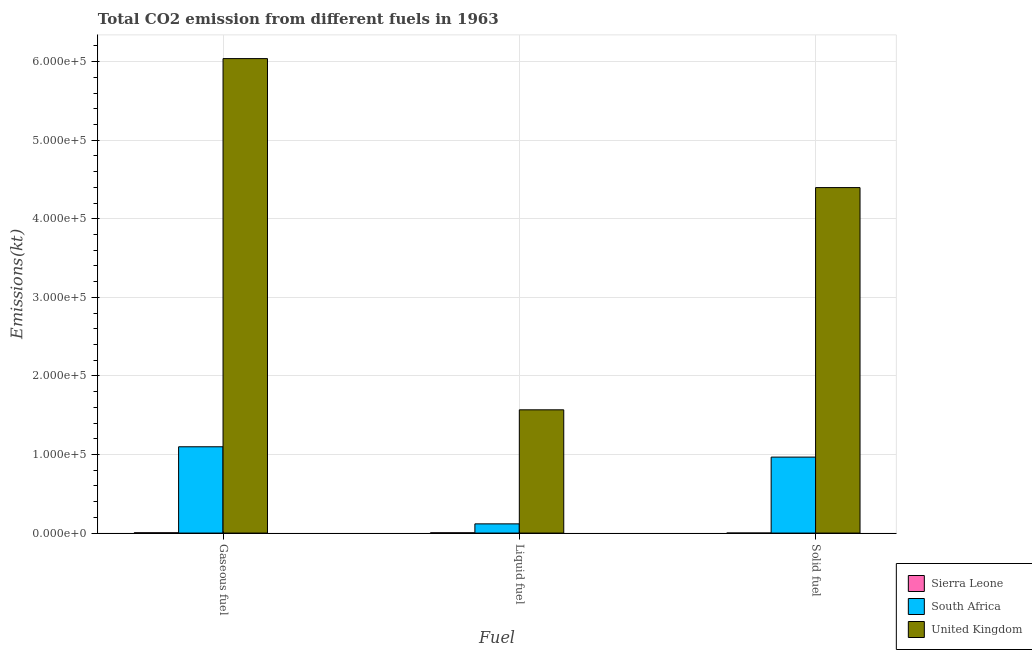How many groups of bars are there?
Provide a succinct answer. 3. Are the number of bars per tick equal to the number of legend labels?
Ensure brevity in your answer.  Yes. How many bars are there on the 2nd tick from the right?
Make the answer very short. 3. What is the label of the 3rd group of bars from the left?
Give a very brief answer. Solid fuel. What is the amount of co2 emissions from gaseous fuel in South Africa?
Make the answer very short. 1.10e+05. Across all countries, what is the maximum amount of co2 emissions from gaseous fuel?
Offer a very short reply. 6.04e+05. Across all countries, what is the minimum amount of co2 emissions from liquid fuel?
Your answer should be very brief. 355.7. In which country was the amount of co2 emissions from gaseous fuel maximum?
Offer a terse response. United Kingdom. In which country was the amount of co2 emissions from liquid fuel minimum?
Offer a very short reply. Sierra Leone. What is the total amount of co2 emissions from liquid fuel in the graph?
Give a very brief answer. 1.69e+05. What is the difference between the amount of co2 emissions from gaseous fuel in South Africa and that in Sierra Leone?
Offer a very short reply. 1.09e+05. What is the difference between the amount of co2 emissions from solid fuel in Sierra Leone and the amount of co2 emissions from gaseous fuel in United Kingdom?
Keep it short and to the point. -6.04e+05. What is the average amount of co2 emissions from solid fuel per country?
Make the answer very short. 1.79e+05. What is the difference between the amount of co2 emissions from solid fuel and amount of co2 emissions from gaseous fuel in South Africa?
Offer a very short reply. -1.31e+04. In how many countries, is the amount of co2 emissions from solid fuel greater than 160000 kt?
Provide a short and direct response. 1. What is the ratio of the amount of co2 emissions from solid fuel in South Africa to that in United Kingdom?
Offer a terse response. 0.22. Is the amount of co2 emissions from gaseous fuel in United Kingdom less than that in South Africa?
Offer a terse response. No. Is the difference between the amount of co2 emissions from gaseous fuel in South Africa and Sierra Leone greater than the difference between the amount of co2 emissions from solid fuel in South Africa and Sierra Leone?
Provide a short and direct response. Yes. What is the difference between the highest and the second highest amount of co2 emissions from liquid fuel?
Keep it short and to the point. 1.45e+05. What is the difference between the highest and the lowest amount of co2 emissions from liquid fuel?
Offer a terse response. 1.57e+05. Is the sum of the amount of co2 emissions from solid fuel in United Kingdom and Sierra Leone greater than the maximum amount of co2 emissions from gaseous fuel across all countries?
Make the answer very short. No. What does the 2nd bar from the left in Solid fuel represents?
Your answer should be compact. South Africa. What does the 2nd bar from the right in Gaseous fuel represents?
Your answer should be very brief. South Africa. How many bars are there?
Keep it short and to the point. 9. Are all the bars in the graph horizontal?
Keep it short and to the point. No. What is the difference between two consecutive major ticks on the Y-axis?
Offer a very short reply. 1.00e+05. Where does the legend appear in the graph?
Make the answer very short. Bottom right. How many legend labels are there?
Ensure brevity in your answer.  3. How are the legend labels stacked?
Offer a terse response. Vertical. What is the title of the graph?
Offer a very short reply. Total CO2 emission from different fuels in 1963. What is the label or title of the X-axis?
Your response must be concise. Fuel. What is the label or title of the Y-axis?
Provide a short and direct response. Emissions(kt). What is the Emissions(kt) of Sierra Leone in Gaseous fuel?
Ensure brevity in your answer.  370.37. What is the Emissions(kt) of South Africa in Gaseous fuel?
Provide a short and direct response. 1.10e+05. What is the Emissions(kt) of United Kingdom in Gaseous fuel?
Make the answer very short. 6.04e+05. What is the Emissions(kt) of Sierra Leone in Liquid fuel?
Offer a very short reply. 355.7. What is the Emissions(kt) of South Africa in Liquid fuel?
Ensure brevity in your answer.  1.17e+04. What is the Emissions(kt) of United Kingdom in Liquid fuel?
Give a very brief answer. 1.57e+05. What is the Emissions(kt) of Sierra Leone in Solid fuel?
Provide a short and direct response. 14.67. What is the Emissions(kt) of South Africa in Solid fuel?
Make the answer very short. 9.67e+04. What is the Emissions(kt) in United Kingdom in Solid fuel?
Provide a short and direct response. 4.40e+05. Across all Fuel, what is the maximum Emissions(kt) of Sierra Leone?
Give a very brief answer. 370.37. Across all Fuel, what is the maximum Emissions(kt) of South Africa?
Ensure brevity in your answer.  1.10e+05. Across all Fuel, what is the maximum Emissions(kt) of United Kingdom?
Ensure brevity in your answer.  6.04e+05. Across all Fuel, what is the minimum Emissions(kt) in Sierra Leone?
Your answer should be compact. 14.67. Across all Fuel, what is the minimum Emissions(kt) of South Africa?
Provide a succinct answer. 1.17e+04. Across all Fuel, what is the minimum Emissions(kt) in United Kingdom?
Offer a very short reply. 1.57e+05. What is the total Emissions(kt) in Sierra Leone in the graph?
Make the answer very short. 740.73. What is the total Emissions(kt) of South Africa in the graph?
Offer a very short reply. 2.18e+05. What is the total Emissions(kt) of United Kingdom in the graph?
Your answer should be compact. 1.20e+06. What is the difference between the Emissions(kt) of Sierra Leone in Gaseous fuel and that in Liquid fuel?
Provide a short and direct response. 14.67. What is the difference between the Emissions(kt) of South Africa in Gaseous fuel and that in Liquid fuel?
Your answer should be compact. 9.81e+04. What is the difference between the Emissions(kt) of United Kingdom in Gaseous fuel and that in Liquid fuel?
Offer a very short reply. 4.47e+05. What is the difference between the Emissions(kt) of Sierra Leone in Gaseous fuel and that in Solid fuel?
Offer a very short reply. 355.7. What is the difference between the Emissions(kt) of South Africa in Gaseous fuel and that in Solid fuel?
Offer a very short reply. 1.31e+04. What is the difference between the Emissions(kt) of United Kingdom in Gaseous fuel and that in Solid fuel?
Keep it short and to the point. 1.64e+05. What is the difference between the Emissions(kt) of Sierra Leone in Liquid fuel and that in Solid fuel?
Offer a terse response. 341.03. What is the difference between the Emissions(kt) of South Africa in Liquid fuel and that in Solid fuel?
Your response must be concise. -8.50e+04. What is the difference between the Emissions(kt) in United Kingdom in Liquid fuel and that in Solid fuel?
Offer a terse response. -2.83e+05. What is the difference between the Emissions(kt) of Sierra Leone in Gaseous fuel and the Emissions(kt) of South Africa in Liquid fuel?
Your answer should be compact. -1.13e+04. What is the difference between the Emissions(kt) of Sierra Leone in Gaseous fuel and the Emissions(kt) of United Kingdom in Liquid fuel?
Offer a very short reply. -1.56e+05. What is the difference between the Emissions(kt) of South Africa in Gaseous fuel and the Emissions(kt) of United Kingdom in Liquid fuel?
Keep it short and to the point. -4.70e+04. What is the difference between the Emissions(kt) of Sierra Leone in Gaseous fuel and the Emissions(kt) of South Africa in Solid fuel?
Offer a terse response. -9.63e+04. What is the difference between the Emissions(kt) of Sierra Leone in Gaseous fuel and the Emissions(kt) of United Kingdom in Solid fuel?
Keep it short and to the point. -4.39e+05. What is the difference between the Emissions(kt) of South Africa in Gaseous fuel and the Emissions(kt) of United Kingdom in Solid fuel?
Make the answer very short. -3.30e+05. What is the difference between the Emissions(kt) of Sierra Leone in Liquid fuel and the Emissions(kt) of South Africa in Solid fuel?
Provide a short and direct response. -9.63e+04. What is the difference between the Emissions(kt) of Sierra Leone in Liquid fuel and the Emissions(kt) of United Kingdom in Solid fuel?
Offer a terse response. -4.39e+05. What is the difference between the Emissions(kt) in South Africa in Liquid fuel and the Emissions(kt) in United Kingdom in Solid fuel?
Keep it short and to the point. -4.28e+05. What is the average Emissions(kt) in Sierra Leone per Fuel?
Your response must be concise. 246.91. What is the average Emissions(kt) of South Africa per Fuel?
Your response must be concise. 7.27e+04. What is the average Emissions(kt) of United Kingdom per Fuel?
Give a very brief answer. 4.00e+05. What is the difference between the Emissions(kt) of Sierra Leone and Emissions(kt) of South Africa in Gaseous fuel?
Offer a very short reply. -1.09e+05. What is the difference between the Emissions(kt) in Sierra Leone and Emissions(kt) in United Kingdom in Gaseous fuel?
Give a very brief answer. -6.03e+05. What is the difference between the Emissions(kt) of South Africa and Emissions(kt) of United Kingdom in Gaseous fuel?
Provide a short and direct response. -4.94e+05. What is the difference between the Emissions(kt) in Sierra Leone and Emissions(kt) in South Africa in Liquid fuel?
Keep it short and to the point. -1.13e+04. What is the difference between the Emissions(kt) of Sierra Leone and Emissions(kt) of United Kingdom in Liquid fuel?
Provide a succinct answer. -1.57e+05. What is the difference between the Emissions(kt) of South Africa and Emissions(kt) of United Kingdom in Liquid fuel?
Provide a short and direct response. -1.45e+05. What is the difference between the Emissions(kt) in Sierra Leone and Emissions(kt) in South Africa in Solid fuel?
Your response must be concise. -9.67e+04. What is the difference between the Emissions(kt) of Sierra Leone and Emissions(kt) of United Kingdom in Solid fuel?
Your answer should be compact. -4.40e+05. What is the difference between the Emissions(kt) of South Africa and Emissions(kt) of United Kingdom in Solid fuel?
Ensure brevity in your answer.  -3.43e+05. What is the ratio of the Emissions(kt) in Sierra Leone in Gaseous fuel to that in Liquid fuel?
Make the answer very short. 1.04. What is the ratio of the Emissions(kt) in South Africa in Gaseous fuel to that in Liquid fuel?
Your response must be concise. 9.38. What is the ratio of the Emissions(kt) of United Kingdom in Gaseous fuel to that in Liquid fuel?
Ensure brevity in your answer.  3.85. What is the ratio of the Emissions(kt) in Sierra Leone in Gaseous fuel to that in Solid fuel?
Ensure brevity in your answer.  25.25. What is the ratio of the Emissions(kt) of South Africa in Gaseous fuel to that in Solid fuel?
Ensure brevity in your answer.  1.14. What is the ratio of the Emissions(kt) in United Kingdom in Gaseous fuel to that in Solid fuel?
Provide a short and direct response. 1.37. What is the ratio of the Emissions(kt) of Sierra Leone in Liquid fuel to that in Solid fuel?
Your response must be concise. 24.25. What is the ratio of the Emissions(kt) in South Africa in Liquid fuel to that in Solid fuel?
Your answer should be very brief. 0.12. What is the ratio of the Emissions(kt) in United Kingdom in Liquid fuel to that in Solid fuel?
Offer a terse response. 0.36. What is the difference between the highest and the second highest Emissions(kt) in Sierra Leone?
Make the answer very short. 14.67. What is the difference between the highest and the second highest Emissions(kt) of South Africa?
Offer a very short reply. 1.31e+04. What is the difference between the highest and the second highest Emissions(kt) of United Kingdom?
Make the answer very short. 1.64e+05. What is the difference between the highest and the lowest Emissions(kt) in Sierra Leone?
Ensure brevity in your answer.  355.7. What is the difference between the highest and the lowest Emissions(kt) of South Africa?
Your answer should be very brief. 9.81e+04. What is the difference between the highest and the lowest Emissions(kt) of United Kingdom?
Your response must be concise. 4.47e+05. 